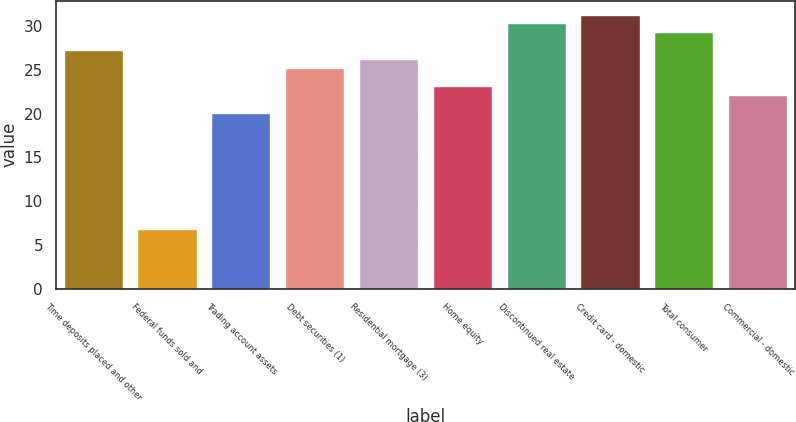Convert chart. <chart><loc_0><loc_0><loc_500><loc_500><bar_chart><fcel>Time deposits placed and other<fcel>Federal funds sold and<fcel>Trading account assets<fcel>Debt securities (1)<fcel>Residential mortgage (3)<fcel>Home equity<fcel>Discontinued real estate<fcel>Credit card - domestic<fcel>Total consumer<fcel>Commercial - domestic<nl><fcel>27.25<fcel>6.85<fcel>20.11<fcel>25.21<fcel>26.23<fcel>23.17<fcel>30.31<fcel>31.33<fcel>29.29<fcel>22.15<nl></chart> 